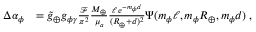Convert formula to latex. <formula><loc_0><loc_0><loc_500><loc_500>\begin{array} { r l } { \Delta \alpha _ { \phi } } & { = { \tilde { g } _ { \oplus } } { g _ { \phi \gamma } } \frac { \mathcal { F } } { \pi ^ { 2 } } \frac { M _ { \oplus } } { \mu _ { a } } \frac { \ell \, e ^ { - m _ { \phi } d } } { ( R _ { \oplus } + d ) ^ { 2 } } \Psi ( m _ { \phi } \ell , m _ { \phi } R _ { \oplus } , m _ { \phi } d ) \, , } \end{array}</formula> 